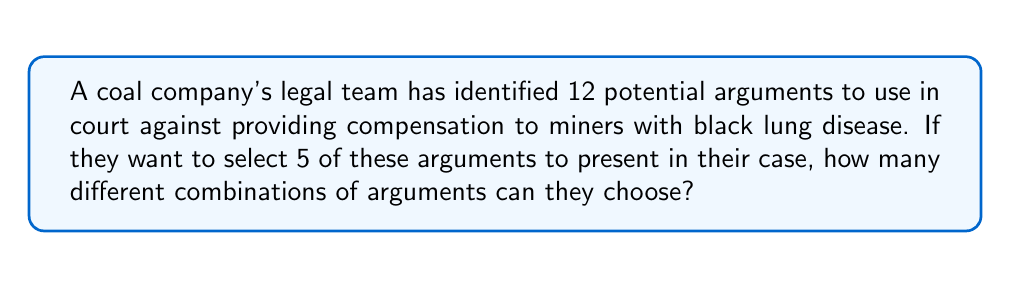Can you answer this question? To solve this problem, we need to use the combination formula. This is because the order of selection doesn't matter (it's not important which argument is presented first, second, etc.), and we're selecting a subset from a larger set without replacement.

The combination formula is:

$${n \choose k} = \frac{n!}{k!(n-k)!}$$

Where:
$n$ = total number of items to choose from
$k$ = number of items being chosen

In this case:
$n = 12$ (total number of potential arguments)
$k = 5$ (number of arguments to be selected)

Let's substitute these values into the formula:

$${12 \choose 5} = \frac{12!}{5!(12-5)!} = \frac{12!}{5!(7)!}$$

Now, let's calculate this step by step:

1) $12! = 479,001,600$
2) $5! = 120$
3) $7! = 5,040$

Substituting these values:

$$\frac{479,001,600}{120 \times 5,040} = \frac{479,001,600}{604,800}$$

Simplifying:

$$792$$

Therefore, there are 792 different combinations of arguments that can be chosen.
Answer: 792 